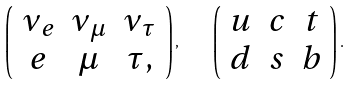Convert formula to latex. <formula><loc_0><loc_0><loc_500><loc_500>\left ( \begin{array} { c c c } \nu _ { e } & \nu _ { \mu } & \nu _ { \tau } \\ e & \mu & \tau , \end{array} \right ) , \quad \left ( \begin{array} { c c c } u & c & t \\ d & s & b \end{array} \right ) .</formula> 